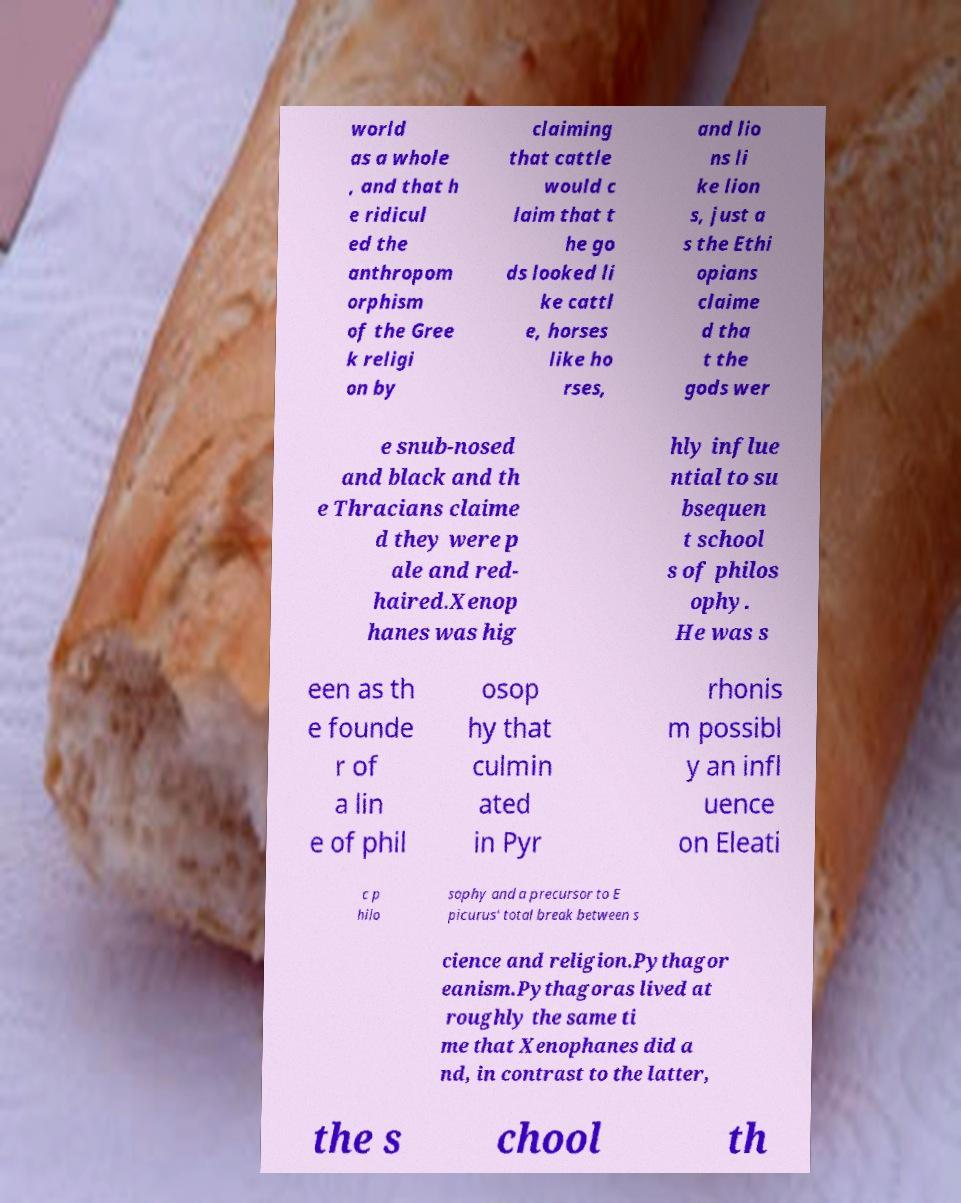Please read and relay the text visible in this image. What does it say? world as a whole , and that h e ridicul ed the anthropom orphism of the Gree k religi on by claiming that cattle would c laim that t he go ds looked li ke cattl e, horses like ho rses, and lio ns li ke lion s, just a s the Ethi opians claime d tha t the gods wer e snub-nosed and black and th e Thracians claime d they were p ale and red- haired.Xenop hanes was hig hly influe ntial to su bsequen t school s of philos ophy. He was s een as th e founde r of a lin e of phil osop hy that culmin ated in Pyr rhonis m possibl y an infl uence on Eleati c p hilo sophy and a precursor to E picurus' total break between s cience and religion.Pythagor eanism.Pythagoras lived at roughly the same ti me that Xenophanes did a nd, in contrast to the latter, the s chool th 